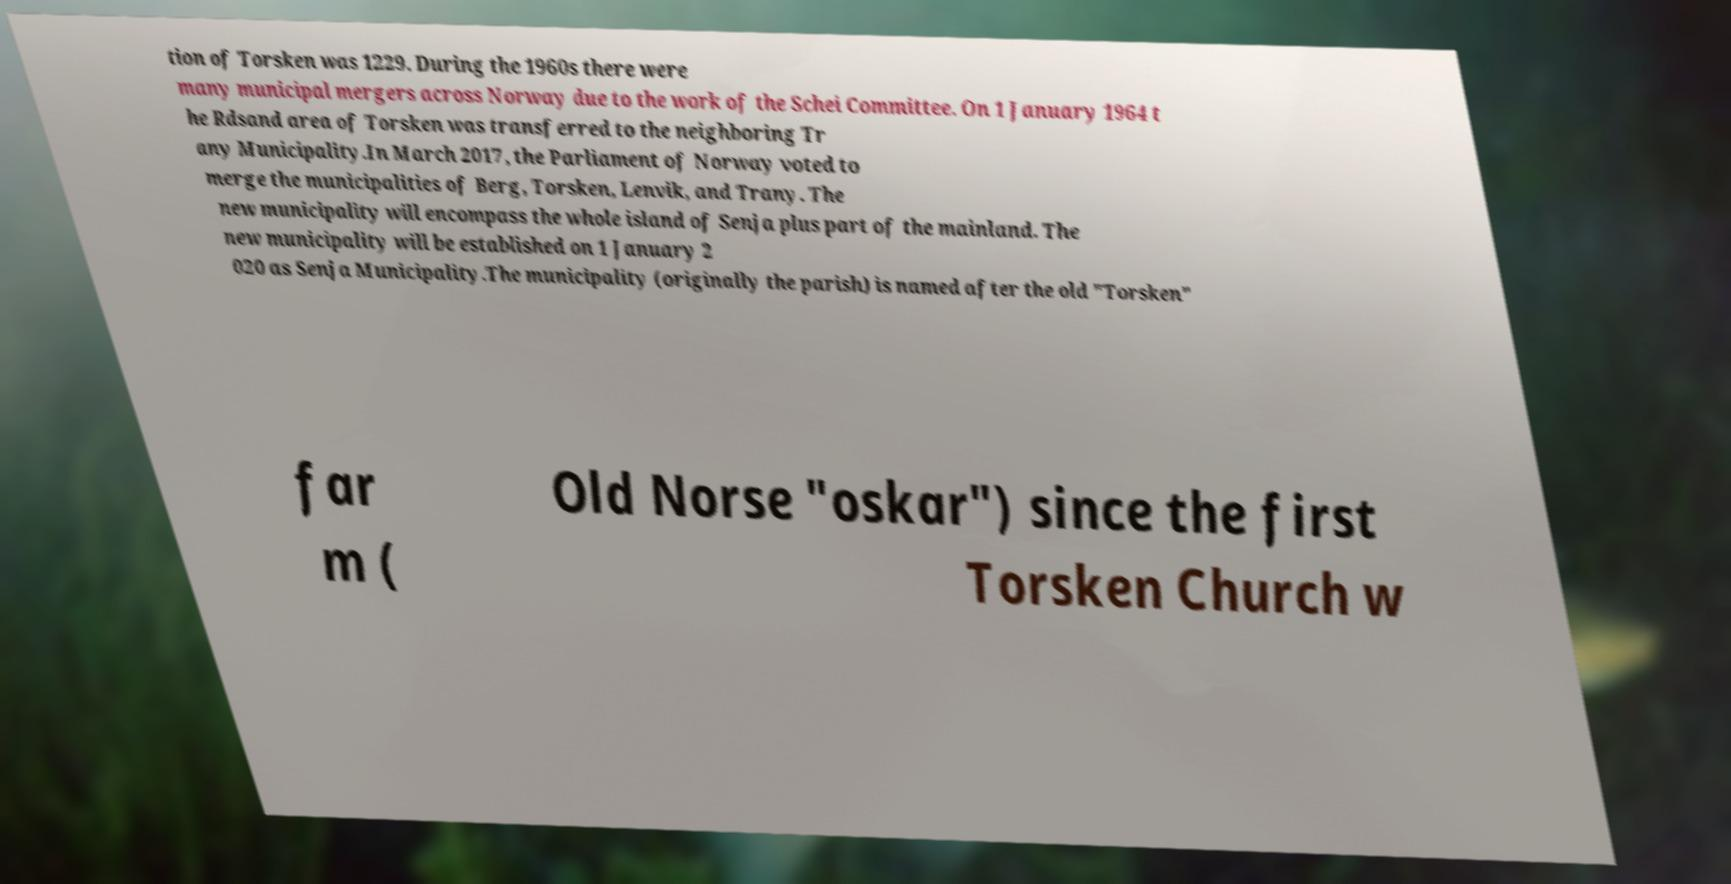There's text embedded in this image that I need extracted. Can you transcribe it verbatim? tion of Torsken was 1229. During the 1960s there were many municipal mergers across Norway due to the work of the Schei Committee. On 1 January 1964 t he Rdsand area of Torsken was transferred to the neighboring Tr any Municipality.In March 2017, the Parliament of Norway voted to merge the municipalities of Berg, Torsken, Lenvik, and Trany. The new municipality will encompass the whole island of Senja plus part of the mainland. The new municipality will be established on 1 January 2 020 as Senja Municipality.The municipality (originally the parish) is named after the old "Torsken" far m ( Old Norse "oskar") since the first Torsken Church w 